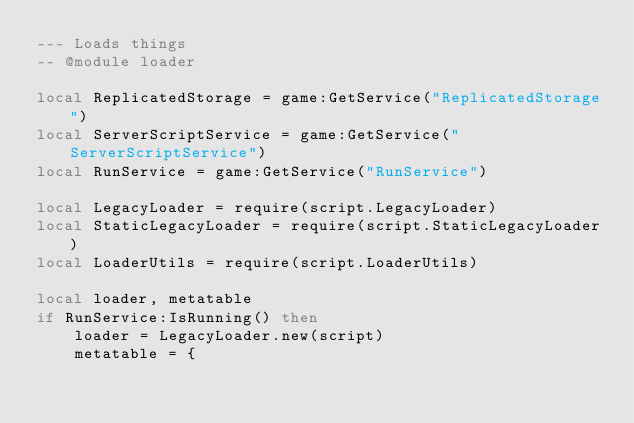<code> <loc_0><loc_0><loc_500><loc_500><_Lua_>--- Loads things
-- @module loader

local ReplicatedStorage = game:GetService("ReplicatedStorage")
local ServerScriptService = game:GetService("ServerScriptService")
local RunService = game:GetService("RunService")

local LegacyLoader = require(script.LegacyLoader)
local StaticLegacyLoader = require(script.StaticLegacyLoader)
local LoaderUtils = require(script.LoaderUtils)

local loader, metatable
if RunService:IsRunning() then
	loader = LegacyLoader.new(script)
	metatable = {</code> 